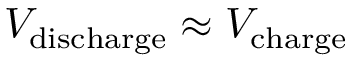Convert formula to latex. <formula><loc_0><loc_0><loc_500><loc_500>V _ { d i s c h \arg e } \approx V _ { c h \arg e }</formula> 